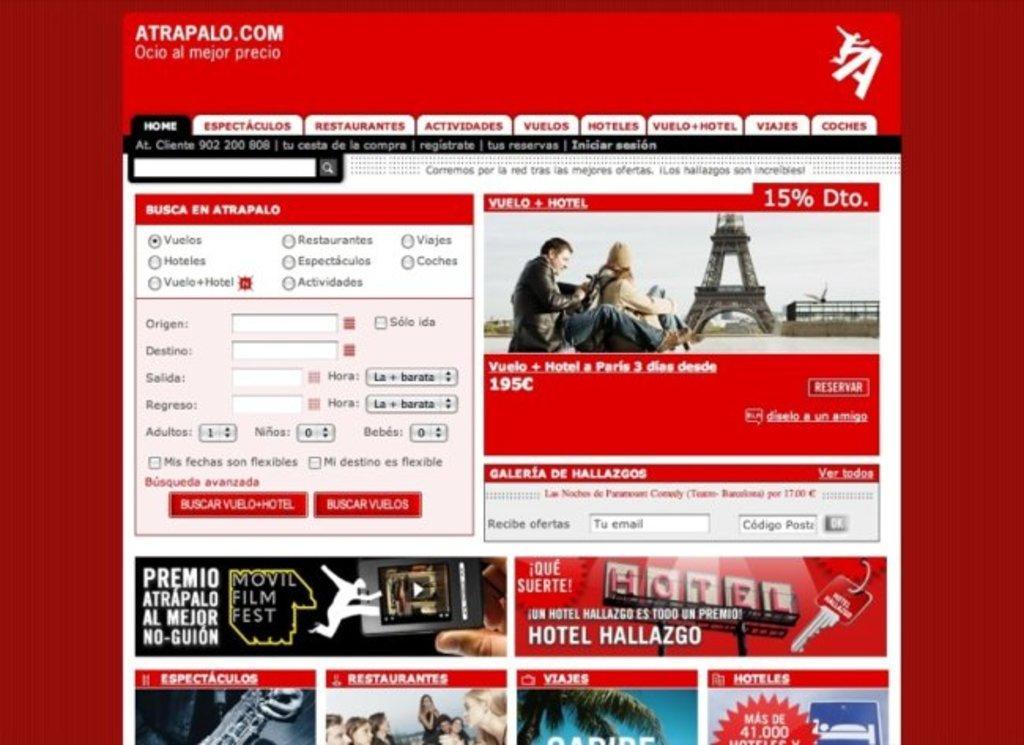Please provide a concise description of this image. In this image, we can see the webpage. 